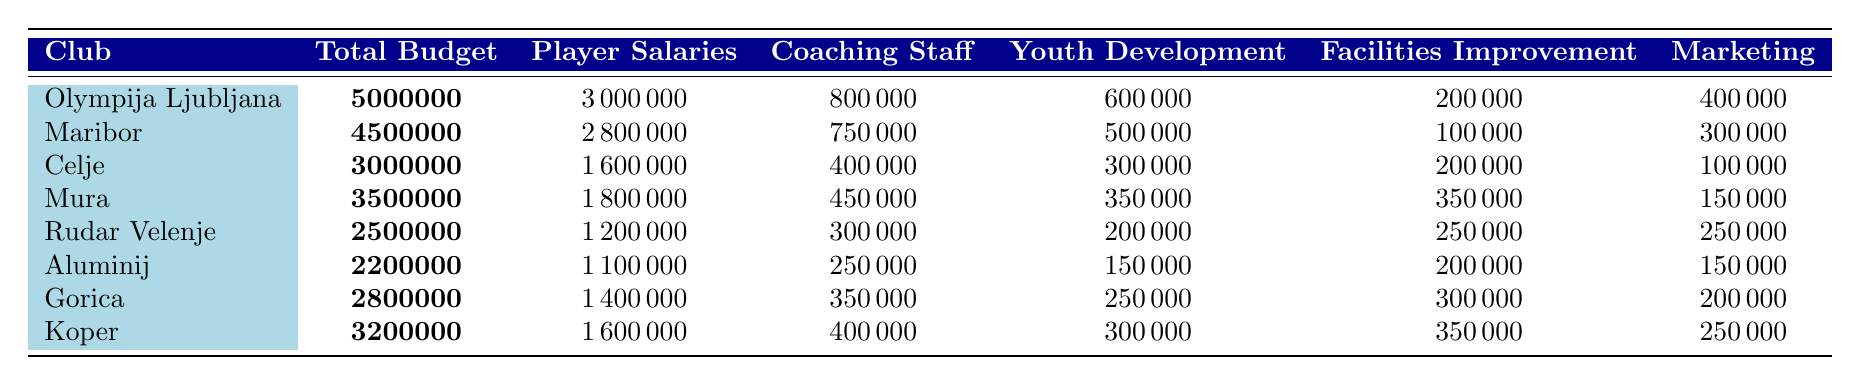What is the total budget of Olympija Ljubljana? Olympija Ljubljana's total budget is explicitly stated in the table, which shows 5,000,000 as the value.
Answer: 5,000,000 Which club has the highest player salaries? By comparing the player salaries across all clubs, Olympija Ljubljana has the highest amount at 3,000,000, which is greater than any other values listed.
Answer: Olympija Ljubljana What is the difference in total budget between Maribor and Koper? Maribor's total budget is 4,500,000 and Koper's total budget is 3,200,000. The difference is calculated as 4,500,000 - 3,200,000 = 1,300,000.
Answer: 1,300,000 How much does Rudar Velenje allocate to marketing? The table indicates that Rudar Velenje spends 250,000 on marketing, which is directly listed under their details.
Answer: 250,000 What percentage of Maribor's budget is spent on player salaries? Maribor's total budget is 4,500,000 and it allocates 2,800,000 for player salaries. The percentage is calculated as (2,800,000 / 4,500,000) * 100 = 62.22%.
Answer: 62.22% Is Celje's youth development budget greater than its coaching staff budget? The table shows Celje spends 300,000 on youth development and 400,000 on coaching staff. Since 300,000 is less than 400,000, the answer is no.
Answer: No Which club has the lowest total budget, and what is its value? Looking at the total budget column, Aluminij has the lowest total budget of 2,200,000. This can be verified by scanning through all club values.
Answer: Aluminij, 2,200,000 What is the average budget allocated to facilities improvement across all clubs? Summing all facilities improvement budgets (200,000 + 100,000 + 200,000 + 350,000 + 250,000 + 200,000 + 300,000 + 350,000) gives 2,050,000, and dividing by the number of clubs (8) results in an average of 256,250.
Answer: 256,250 Which club invests the most in youth development and what is the amount? By reviewing the youth development budget, Olympija Ljubljana invests the most with an allocation of 600,000. This figure is the highest when compared among all clubs listed.
Answer: Olympija Ljubljana, 600,000 How much more does Koper spend on facilities improvement compared to Aluminij? Koper allocates 350,000 and Aluminij allocates 200,000 for facilities improvement. The difference is calculated as 350,000 - 200,000 = 150,000.
Answer: 150,000 